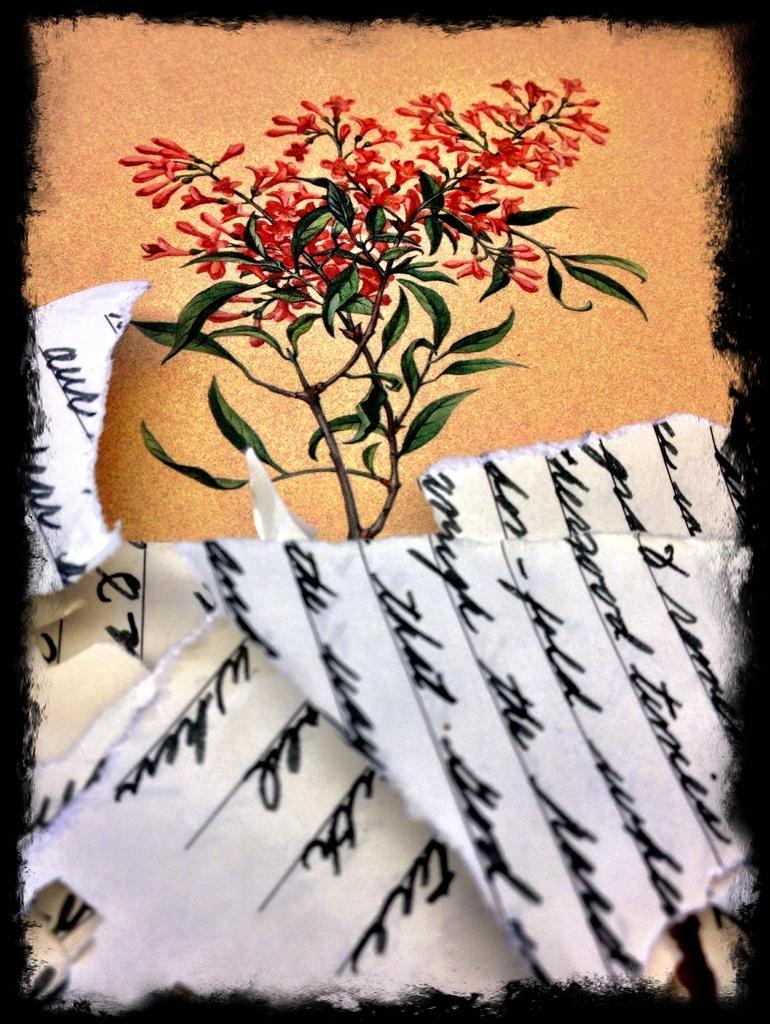Could you give a brief overview of what you see in this image? In this picture we can see a paper here, we can see painting of a flower plant here. 